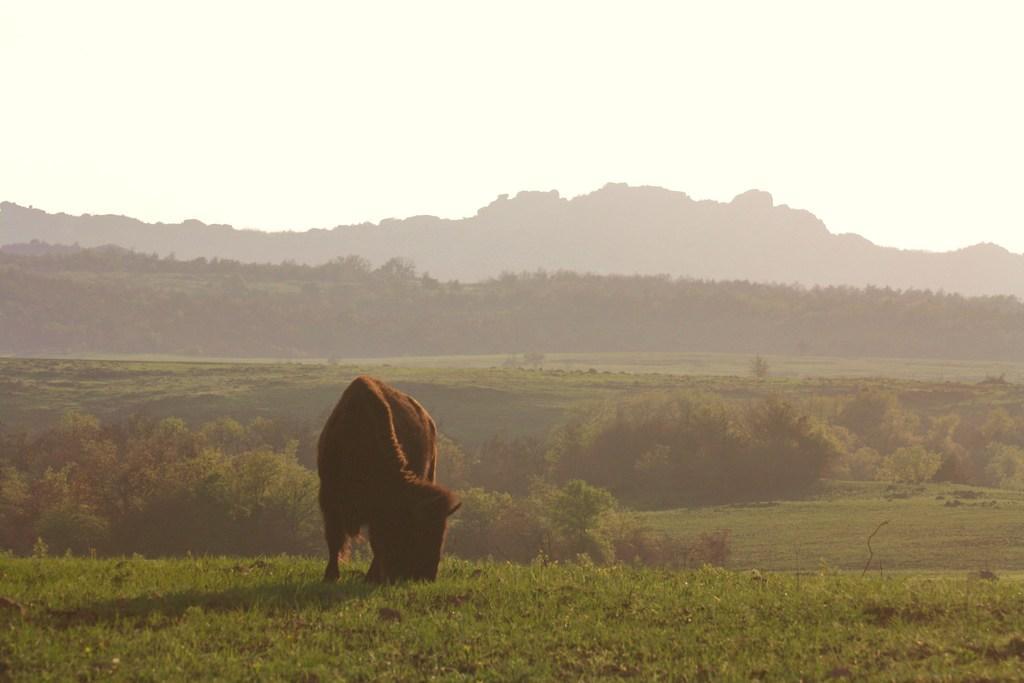Could you give a brief overview of what you see in this image? In this image there is a bison eating the grass. In the background of the image there are trees, mountains and sky. 